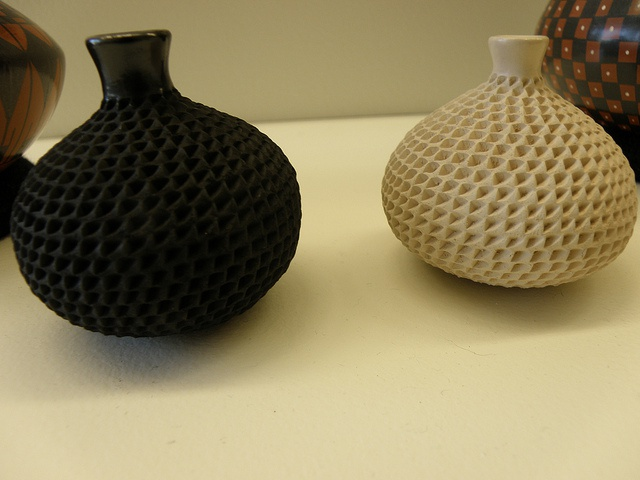Describe the objects in this image and their specific colors. I can see vase in gray, black, tan, and olive tones, vase in gray, tan, and olive tones, vase in gray, black, and maroon tones, and vase in olive, black, and maroon tones in this image. 